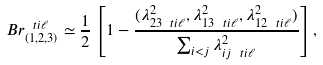Convert formula to latex. <formula><loc_0><loc_0><loc_500><loc_500>B r ^ { \ t i \ell } _ { ( 1 , 2 , 3 ) } \simeq \frac { 1 } { 2 } \left [ 1 - \frac { ( \lambda _ { 2 3 \ t i \ell } ^ { 2 } , \lambda _ { 1 3 \ t i \ell } ^ { 2 } , \lambda _ { 1 2 \ t i \ell } ^ { 2 } ) } { \sum _ { i < j } \lambda _ { i j \ t i \ell } ^ { 2 } } \right ] ,</formula> 